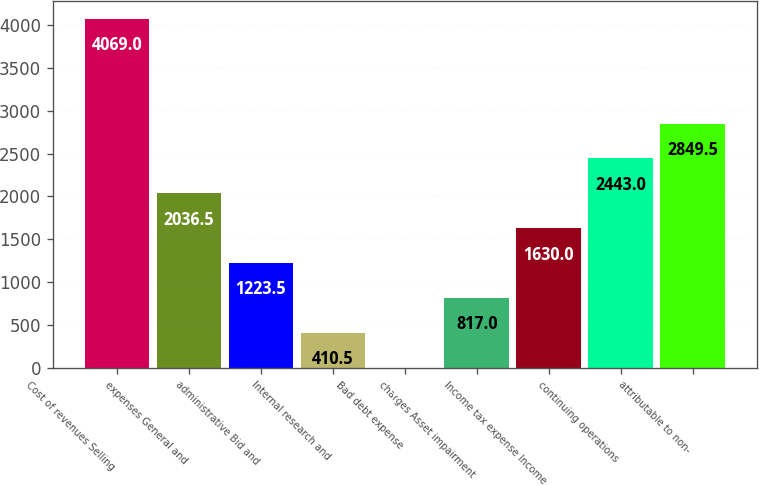Convert chart. <chart><loc_0><loc_0><loc_500><loc_500><bar_chart><fcel>Cost of revenues Selling<fcel>expenses General and<fcel>administrative Bid and<fcel>Internal research and<fcel>Bad debt expense<fcel>charges Asset impairment<fcel>Income tax expense Income<fcel>continuing operations<fcel>attributable to non-<nl><fcel>4069<fcel>2036.5<fcel>1223.5<fcel>410.5<fcel>4<fcel>817<fcel>1630<fcel>2443<fcel>2849.5<nl></chart> 